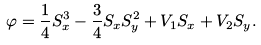Convert formula to latex. <formula><loc_0><loc_0><loc_500><loc_500>\varphi = \frac { 1 } { 4 } S _ { x } ^ { 3 } - \frac { 3 } { 4 } S _ { x } S _ { y } ^ { 2 } + V _ { 1 } S _ { x } + V _ { 2 } S _ { y } .</formula> 